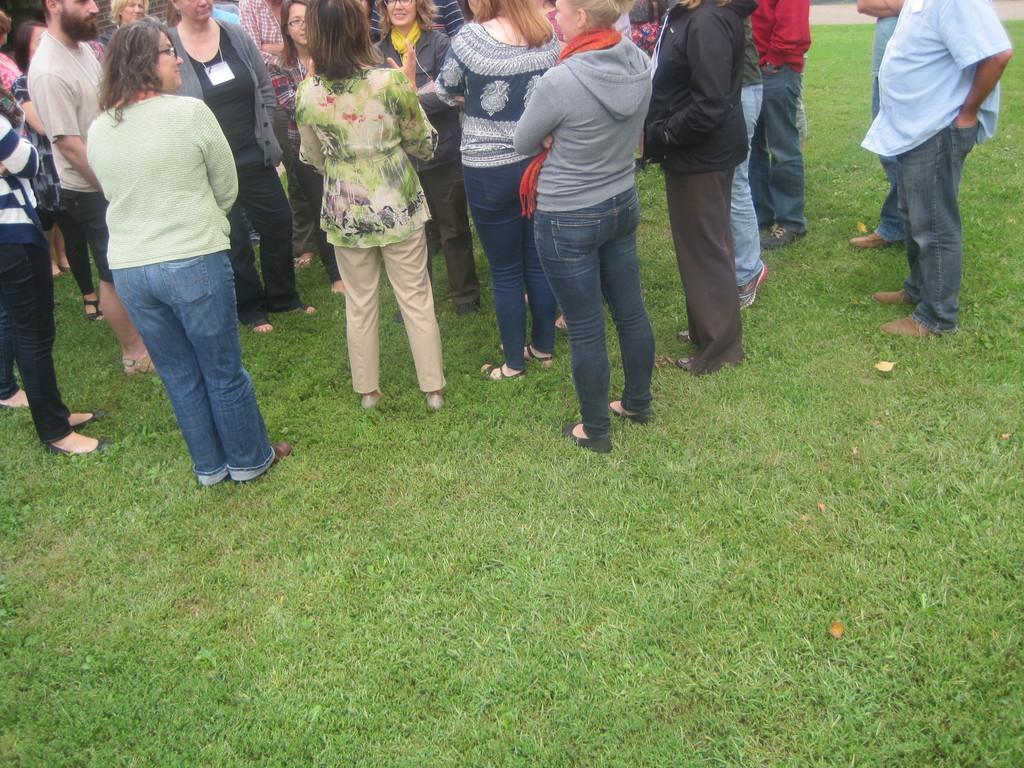How many people are in the image? The number of people in the image cannot be determined from the provided facts. What is the surface that the people are standing on? The people are standing on the grass. What type of pan can be seen in the market in the image? There is no pan or market present in the image; it only shows people standing on the grass. 